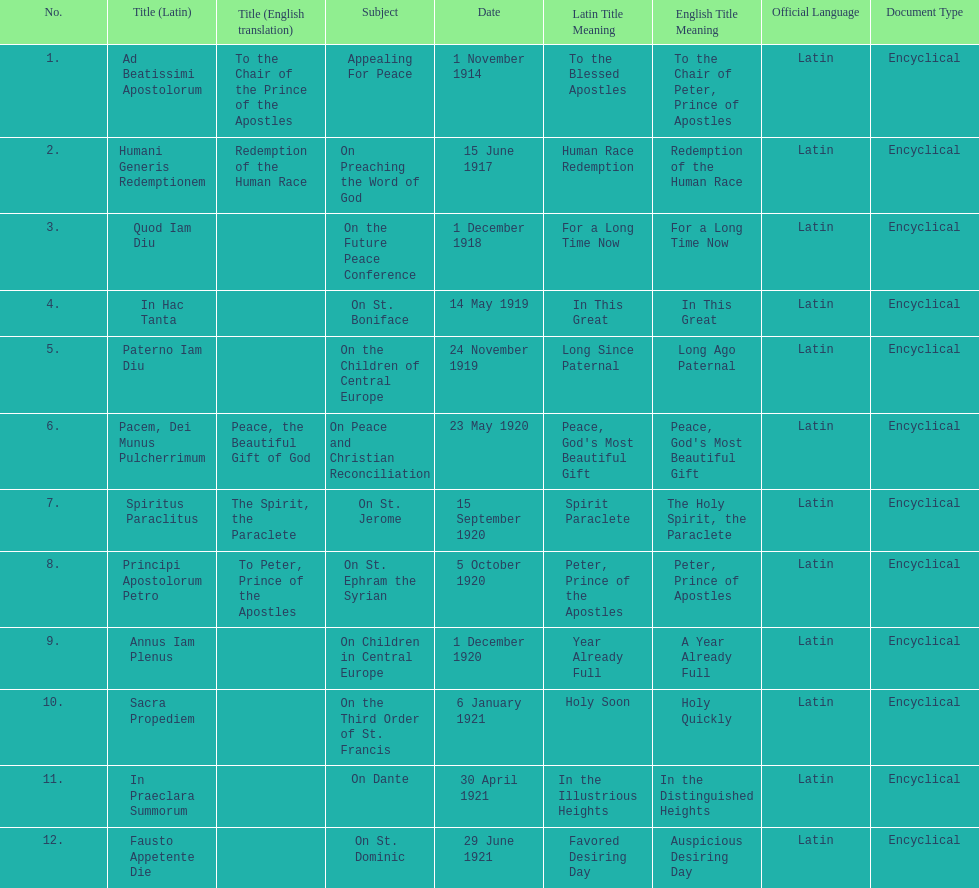How long after quod iam diu was paterno iam diu issued? 11 months. 